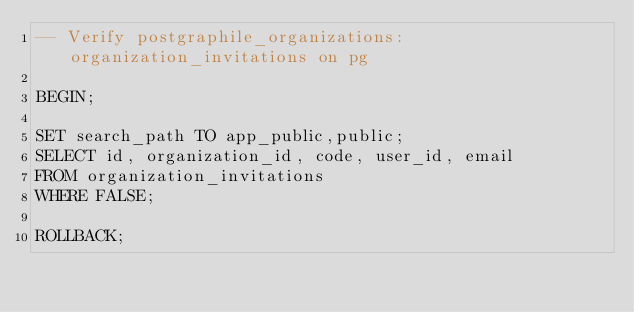<code> <loc_0><loc_0><loc_500><loc_500><_SQL_>-- Verify postgraphile_organizations:organization_invitations on pg

BEGIN;

SET search_path TO app_public,public;
SELECT id, organization_id, code, user_id, email
FROM organization_invitations
WHERE FALSE;

ROLLBACK;
</code> 